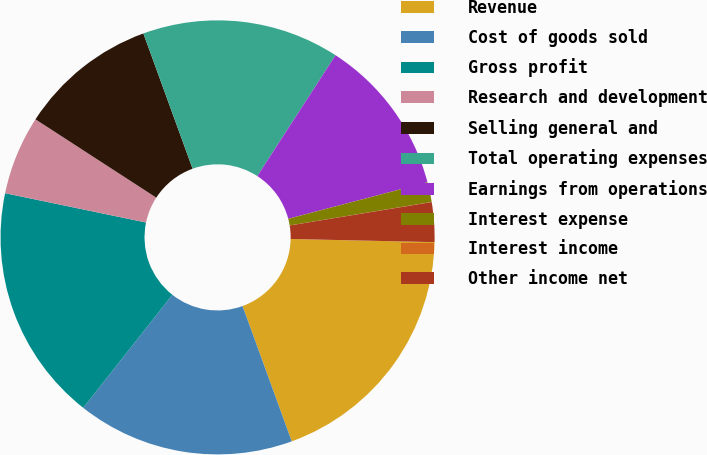<chart> <loc_0><loc_0><loc_500><loc_500><pie_chart><fcel>Revenue<fcel>Cost of goods sold<fcel>Gross profit<fcel>Research and development<fcel>Selling general and<fcel>Total operating expenses<fcel>Earnings from operations<fcel>Interest expense<fcel>Interest income<fcel>Other income net<nl><fcel>19.1%<fcel>16.17%<fcel>17.64%<fcel>5.89%<fcel>10.29%<fcel>14.7%<fcel>11.76%<fcel>1.48%<fcel>0.01%<fcel>2.95%<nl></chart> 